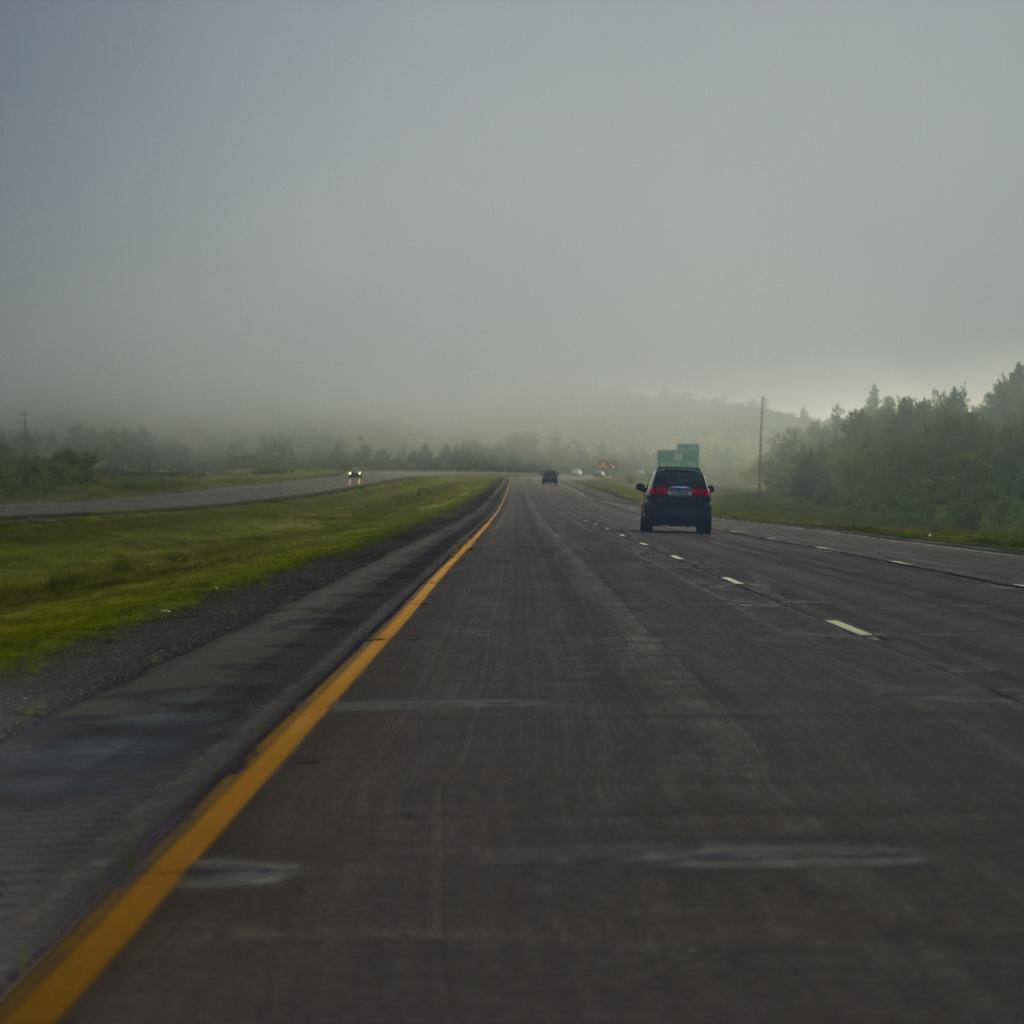What can be seen on the road in the image? There are vehicles on the road in the image. What is the surface that the vehicles are traveling on? The road is visible in the image. What type of vegetation is near the road? Grass is present near the road. What markings are on the road? There are white and yellow lines on the road. What structure can be seen in the image? There is a pole in the image. How would you describe the appearance of the sky in the image? The sky appears smoky in the image. What type of umbrella is being used by the sun in the image? There is no sun or umbrella present in the image. What action is the pole performing in the image? The pole is an inanimate object and does not perform any actions in the image. 